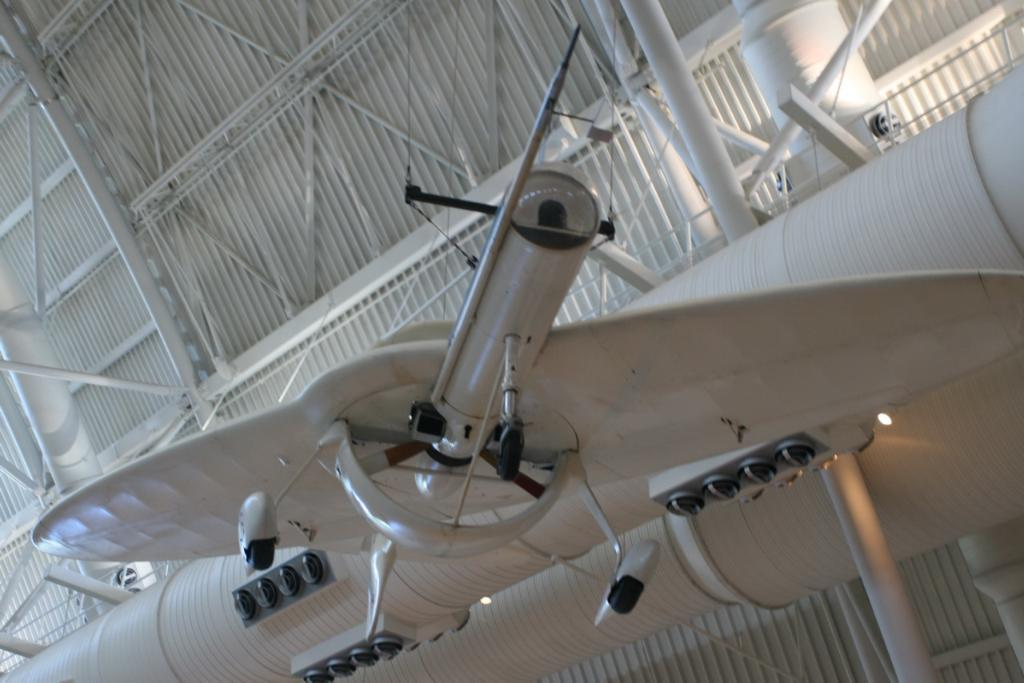What is the main subject of the image? The main subject of the image is an aircraft. What is the color of the aircraft? The aircraft is cream in color. How is the aircraft positioned in the image? The aircraft is hanged from the ceiling. What else can be seen in the image besides the aircraft? There are lights and metal rods visible in the image. What is the color of the ceiling in the image? The ceiling is cream colored. What type of rabbit is sitting on the committee in the image? There is no rabbit or committee present in the image; it features an aircraft hanging from the ceiling. What kind of support is the aircraft using to stay suspended in the image? The aircraft is hanged from the ceiling using metal rods, which provide the necessary support. 